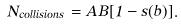Convert formula to latex. <formula><loc_0><loc_0><loc_500><loc_500>N _ { c o l l i s i o n s } = A B [ 1 - s ( b ) ] .</formula> 